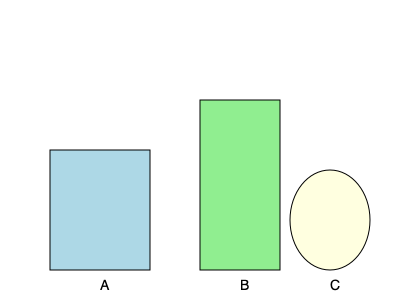In the kitchen of the diner where your tutored teens work, there are three food containers as shown above. Container A is a rectangular prism, B is a tall cylinder, and C is a spherical bowl. If the volume of container A is 6 liters, estimate the volumes of containers B and C in liters. Let's approach this step-by-step:

1) First, we need to estimate the relative dimensions of the containers:
   - Container A: approx. 10 units wide, 10 units deep, 12 units tall
   - Container B: approx. 8 units wide/deep, 17 units tall
   - Container C: approx. 8 units in diameter

2) We know the volume of container A is 6 liters. Let's use this as a reference:
   Volume of A = $10 \times 10 \times 12 = 1200$ cubic units = 6 liters

3) So, 1 liter = 200 cubic units

4) For container B (cylinder):
   Volume = $\pi r^2 h$
   $V_B = \pi \times 4^2 \times 17 \approx 855$ cubic units
   $V_B \approx 855 / 200 \approx 4.3$ liters

5) For container C (sphere):
   Volume = $\frac{4}{3}\pi r^3$
   $V_C = \frac{4}{3}\pi \times 4^3 \approx 268$ cubic units
   $V_C \approx 268 / 200 \approx 1.3$ liters

6) Rounding to the nearest liter:
   Container B: 4 liters
   Container C: 1 liter
Answer: B: 4 liters, C: 1 liter 